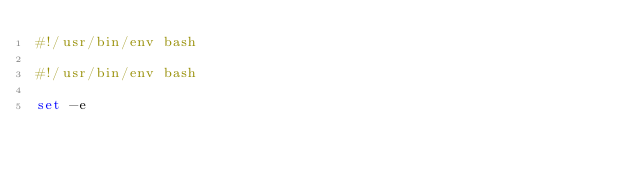Convert code to text. <code><loc_0><loc_0><loc_500><loc_500><_Bash_>#!/usr/bin/env bash

#!/usr/bin/env bash

set -e
</code> 